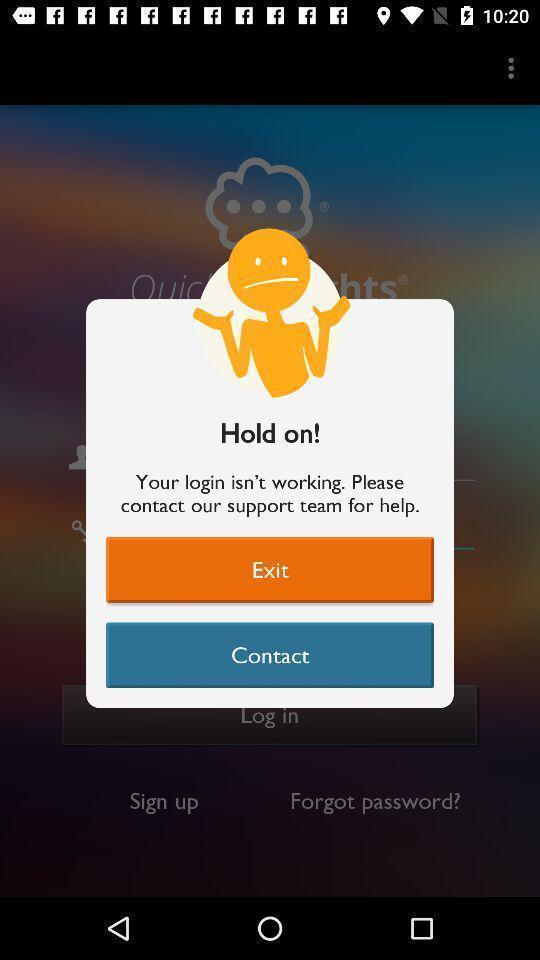What is the overall content of this screenshot? Pop-up showing to hold on. 